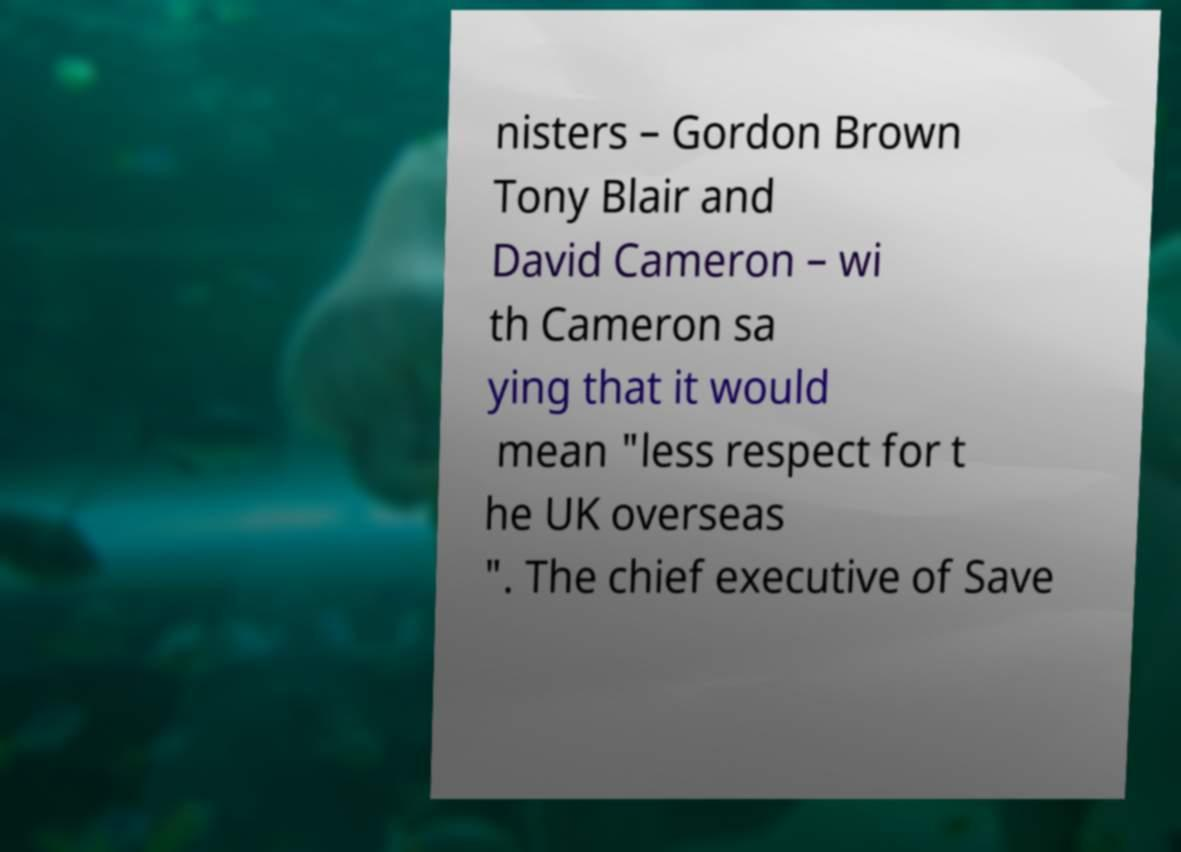There's text embedded in this image that I need extracted. Can you transcribe it verbatim? nisters – Gordon Brown Tony Blair and David Cameron – wi th Cameron sa ying that it would mean "less respect for t he UK overseas ". The chief executive of Save 